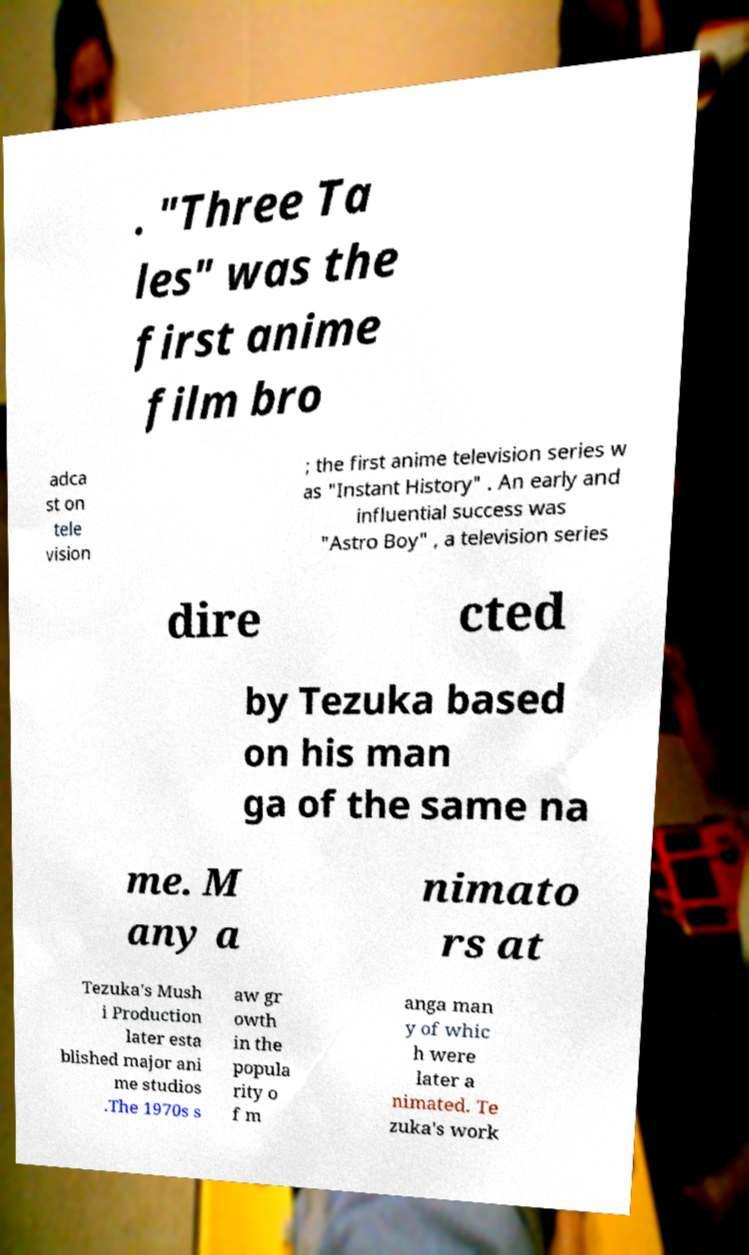What messages or text are displayed in this image? I need them in a readable, typed format. . "Three Ta les" was the first anime film bro adca st on tele vision ; the first anime television series w as "Instant History" . An early and influential success was "Astro Boy" , a television series dire cted by Tezuka based on his man ga of the same na me. M any a nimato rs at Tezuka's Mush i Production later esta blished major ani me studios .The 1970s s aw gr owth in the popula rity o f m anga man y of whic h were later a nimated. Te zuka's work 